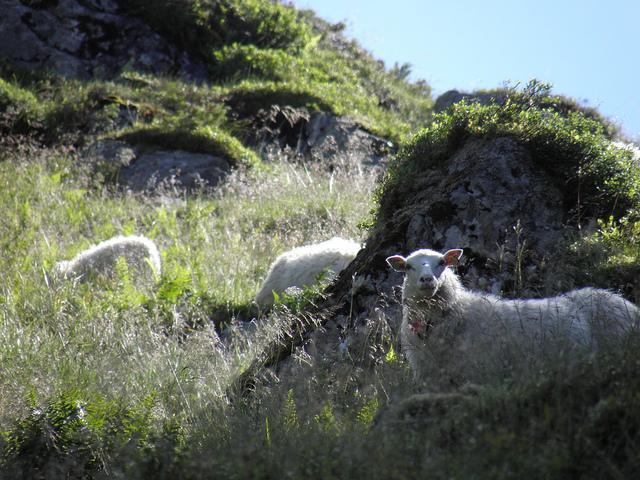How many sheep are in the photo?
Give a very brief answer. 3. How many chairs are around the table?
Give a very brief answer. 0. 